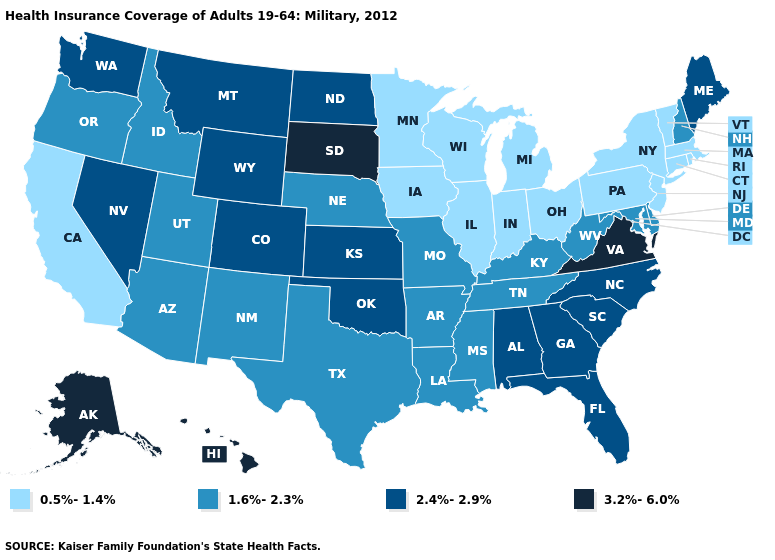Is the legend a continuous bar?
Be succinct. No. Name the states that have a value in the range 2.4%-2.9%?
Concise answer only. Alabama, Colorado, Florida, Georgia, Kansas, Maine, Montana, Nevada, North Carolina, North Dakota, Oklahoma, South Carolina, Washington, Wyoming. Name the states that have a value in the range 1.6%-2.3%?
Give a very brief answer. Arizona, Arkansas, Delaware, Idaho, Kentucky, Louisiana, Maryland, Mississippi, Missouri, Nebraska, New Hampshire, New Mexico, Oregon, Tennessee, Texas, Utah, West Virginia. Does Louisiana have a higher value than Hawaii?
Quick response, please. No. Among the states that border Kansas , does Nebraska have the lowest value?
Answer briefly. Yes. What is the value of Virginia?
Concise answer only. 3.2%-6.0%. What is the lowest value in states that border Maryland?
Short answer required. 0.5%-1.4%. Among the states that border Colorado , does Oklahoma have the lowest value?
Concise answer only. No. Which states have the highest value in the USA?
Quick response, please. Alaska, Hawaii, South Dakota, Virginia. What is the lowest value in the West?
Be succinct. 0.5%-1.4%. Name the states that have a value in the range 2.4%-2.9%?
Answer briefly. Alabama, Colorado, Florida, Georgia, Kansas, Maine, Montana, Nevada, North Carolina, North Dakota, Oklahoma, South Carolina, Washington, Wyoming. Does Arizona have the same value as Idaho?
Be succinct. Yes. Does Illinois have the highest value in the USA?
Concise answer only. No. Does Kentucky have the lowest value in the USA?
Be succinct. No. What is the highest value in the West ?
Keep it brief. 3.2%-6.0%. 